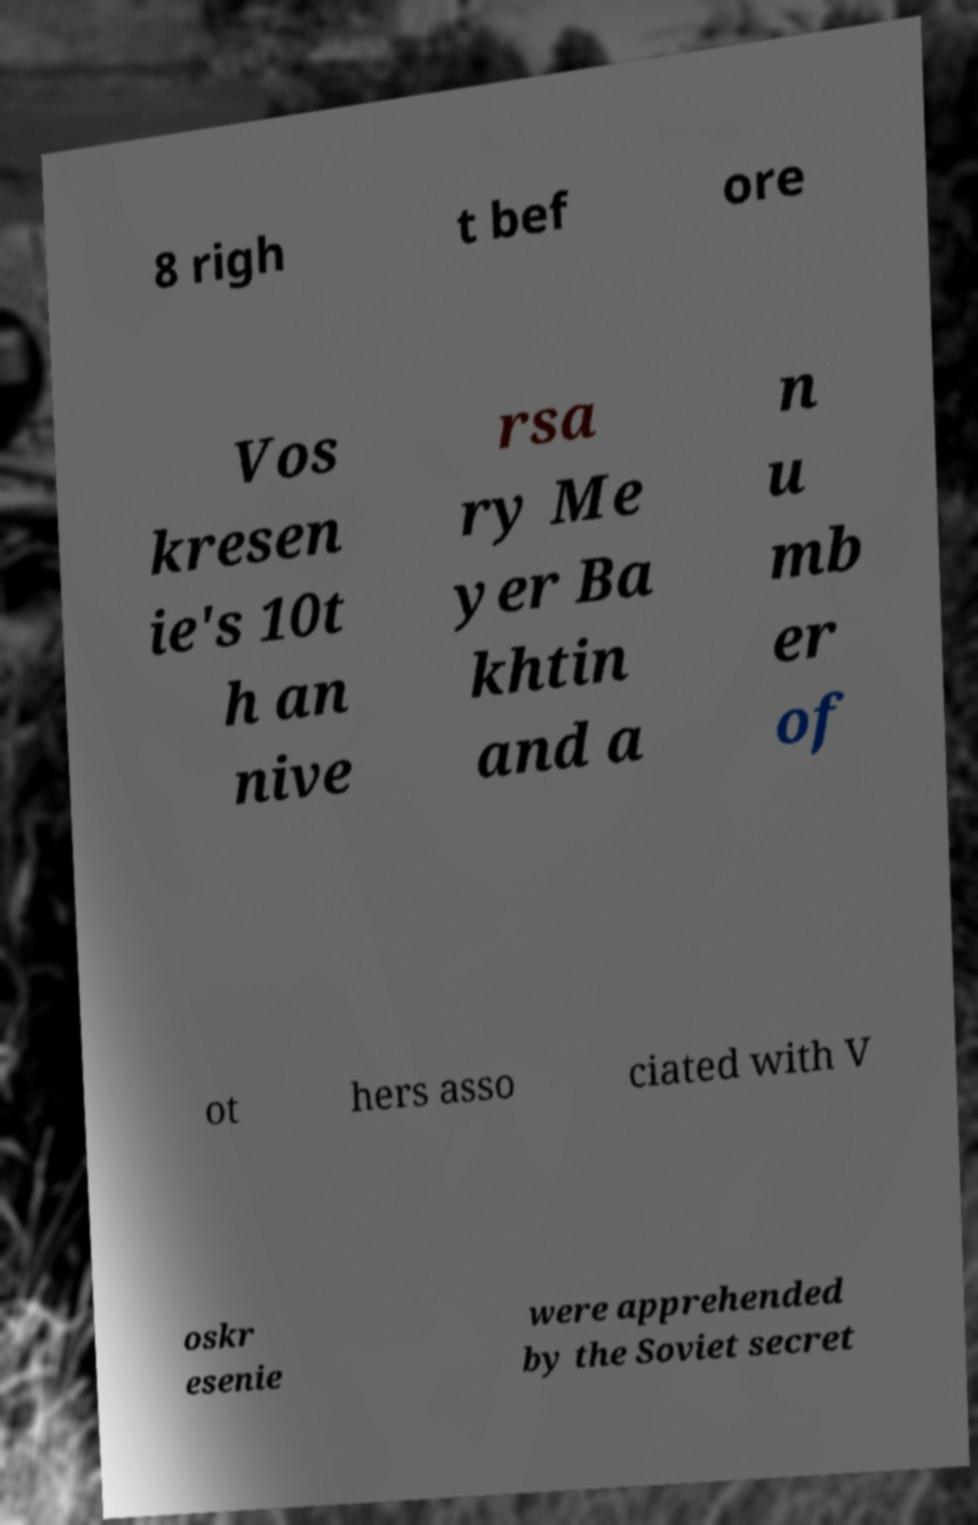Could you extract and type out the text from this image? 8 righ t bef ore Vos kresen ie's 10t h an nive rsa ry Me yer Ba khtin and a n u mb er of ot hers asso ciated with V oskr esenie were apprehended by the Soviet secret 